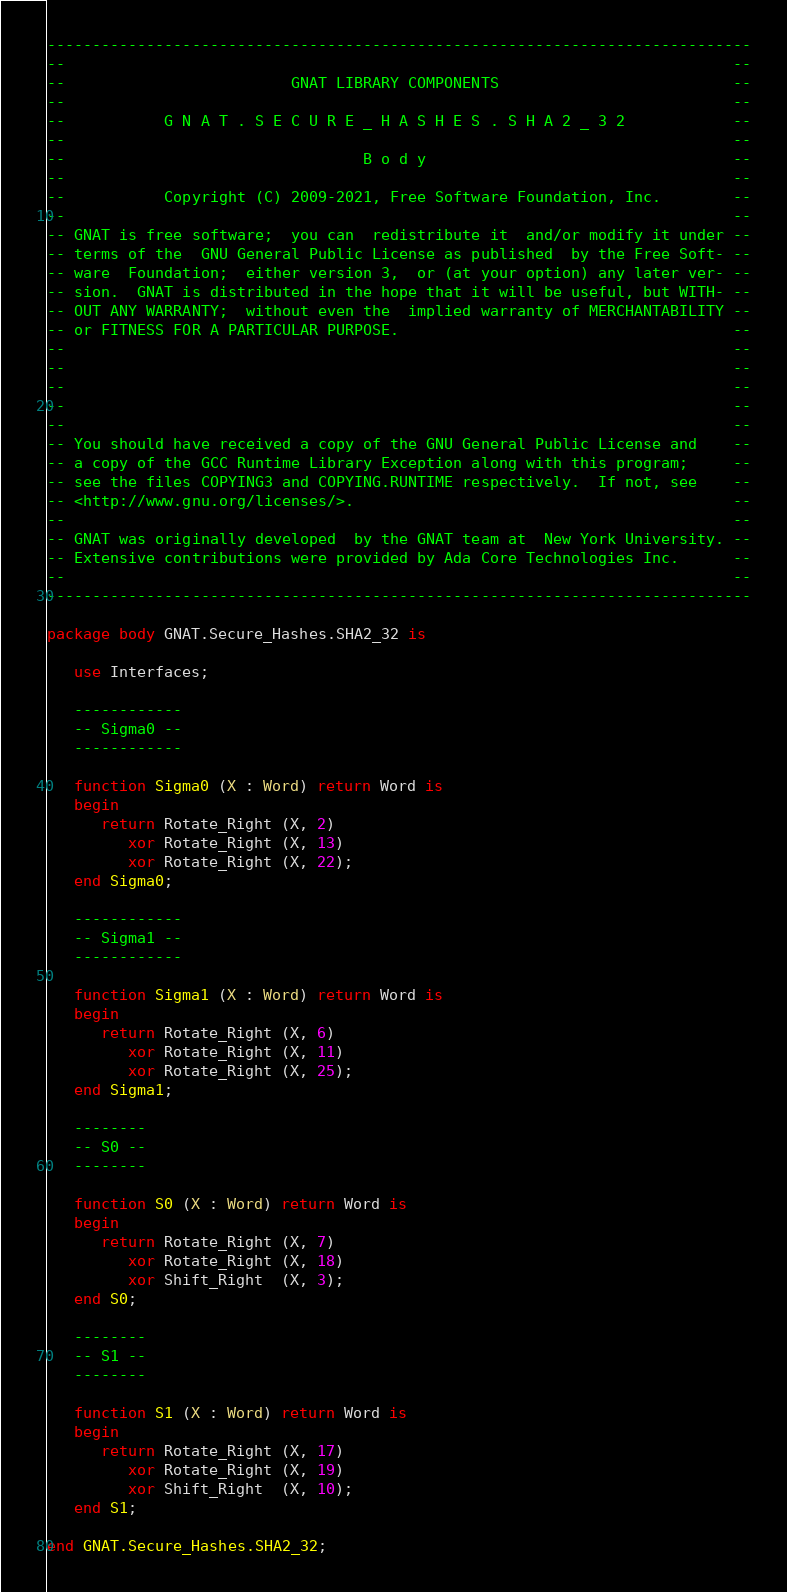<code> <loc_0><loc_0><loc_500><loc_500><_Ada_>------------------------------------------------------------------------------
--                                                                          --
--                         GNAT LIBRARY COMPONENTS                          --
--                                                                          --
--           G N A T . S E C U R E _ H A S H E S . S H A 2 _ 3 2            --
--                                                                          --
--                                 B o d y                                  --
--                                                                          --
--           Copyright (C) 2009-2021, Free Software Foundation, Inc.        --
--                                                                          --
-- GNAT is free software;  you can  redistribute it  and/or modify it under --
-- terms of the  GNU General Public License as published  by the Free Soft- --
-- ware  Foundation;  either version 3,  or (at your option) any later ver- --
-- sion.  GNAT is distributed in the hope that it will be useful, but WITH- --
-- OUT ANY WARRANTY;  without even the  implied warranty of MERCHANTABILITY --
-- or FITNESS FOR A PARTICULAR PURPOSE.                                     --
--                                                                          --
--                                                                          --
--                                                                          --
--                                                                          --
--                                                                          --
-- You should have received a copy of the GNU General Public License and    --
-- a copy of the GCC Runtime Library Exception along with this program;     --
-- see the files COPYING3 and COPYING.RUNTIME respectively.  If not, see    --
-- <http://www.gnu.org/licenses/>.                                          --
--                                                                          --
-- GNAT was originally developed  by the GNAT team at  New York University. --
-- Extensive contributions were provided by Ada Core Technologies Inc.      --
--                                                                          --
------------------------------------------------------------------------------

package body GNAT.Secure_Hashes.SHA2_32 is

   use Interfaces;

   ------------
   -- Sigma0 --
   ------------

   function Sigma0 (X : Word) return Word is
   begin
      return Rotate_Right (X, 2)
         xor Rotate_Right (X, 13)
         xor Rotate_Right (X, 22);
   end Sigma0;

   ------------
   -- Sigma1 --
   ------------

   function Sigma1 (X : Word) return Word is
   begin
      return Rotate_Right (X, 6)
         xor Rotate_Right (X, 11)
         xor Rotate_Right (X, 25);
   end Sigma1;

   --------
   -- S0 --
   --------

   function S0 (X : Word) return Word is
   begin
      return Rotate_Right (X, 7)
         xor Rotate_Right (X, 18)
         xor Shift_Right  (X, 3);
   end S0;

   --------
   -- S1 --
   --------

   function S1 (X : Word) return Word is
   begin
      return Rotate_Right (X, 17)
         xor Rotate_Right (X, 19)
         xor Shift_Right  (X, 10);
   end S1;

end GNAT.Secure_Hashes.SHA2_32;
</code> 